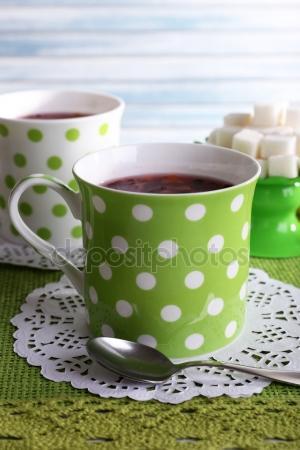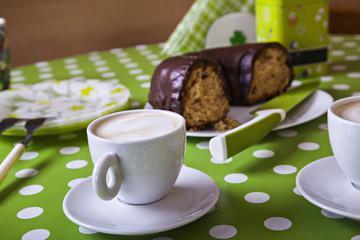The first image is the image on the left, the second image is the image on the right. For the images displayed, is the sentence "Brown liquid sits in a single mug in the cup on the left." factually correct? Answer yes or no. No. The first image is the image on the left, the second image is the image on the right. Given the left and right images, does the statement "There are no less than two coffee mugs with handles" hold true? Answer yes or no. Yes. 